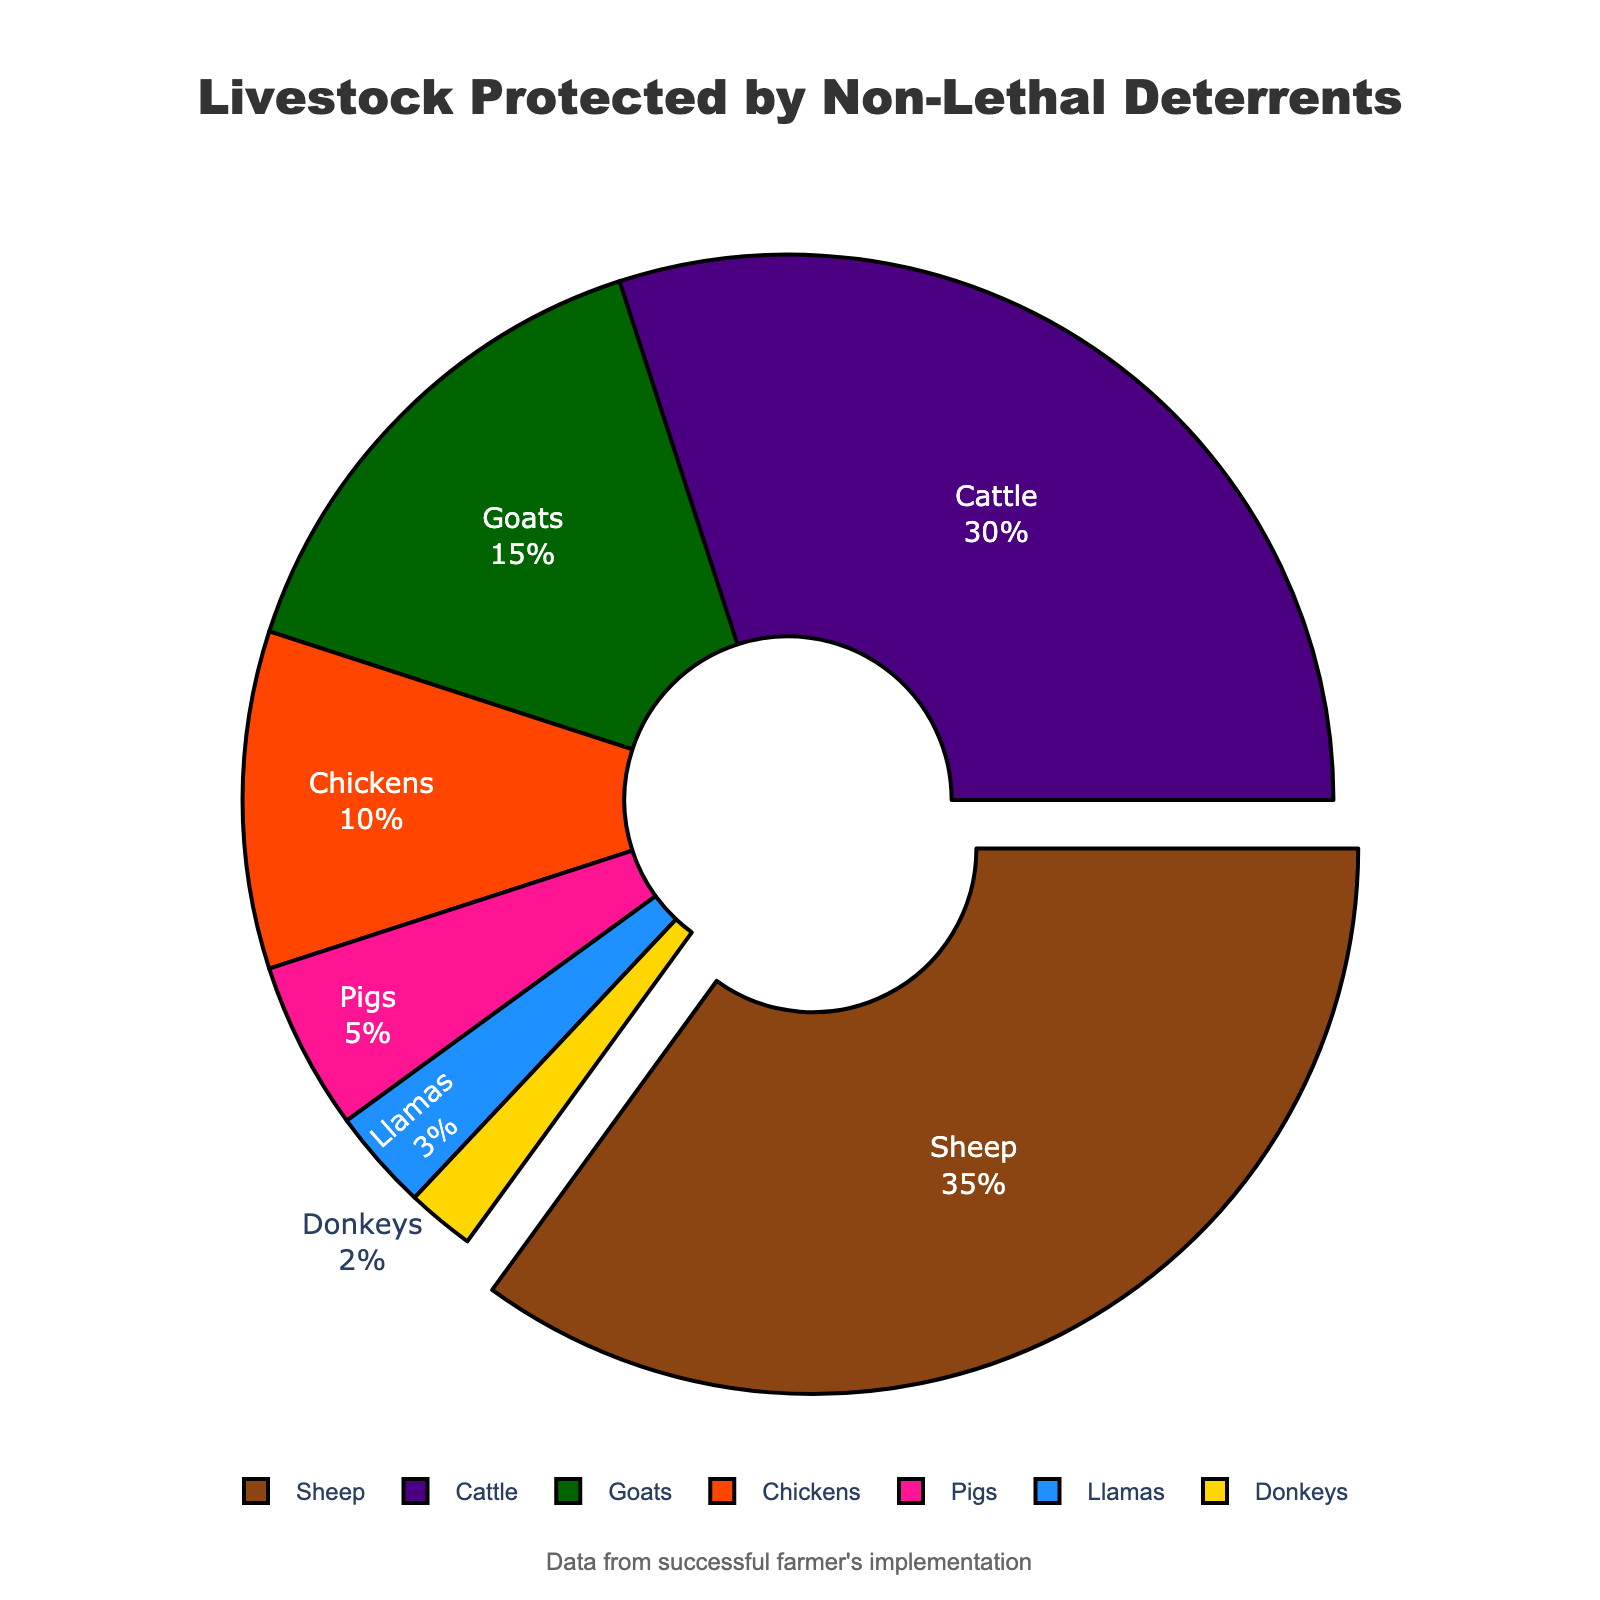What is the species with the highest percentage of livestock protected by non-lethal deterrents? The pie chart highlights the sheep segment by slightly pulling it out from the rest, indicating it has the highest percentage. Upon checking the data labels in the chart, the highest value is 35% for sheep.
Answer: Sheep How much more percentage does sheep contribute to the protected livestock compared to pigs? From the pie chart data, the percentage for sheep is 35% and for pigs, it is 5%. The difference between them is 35% - 5%.
Answer: 30% What is the total percentage of livestock protected by non-lethal deterrents for cattle and goats combined? The chart shows that cattle have a percentage of 30% and goats have 15%. Adding these two percentages gives 30% + 15%.
Answer: 45% Is the percentage of chickens protected by non-lethal deterrents greater than or less than the percentage of goats? The pie chart indicates that the percentage for chickens is 10% and for goats is 15%. Thus, the percentage of chickens is less than that of goats.
Answer: Less than Which species has the least percentage representation in the chart, and what is that percentage? According to the chart, the segment representing donkeys is the smallest, and the label indicates 2%.
Answer: Donkeys, 2% What is the sum of the percentages of livestock protected that are represented by pigs, llamas, and donkeys? In the chart, pigs have 5%, llamas 3%, and donkeys 2%. Adding these percentages together gives 5% + 3% + 2%.
Answer: 10% Which species comprise less than 10% each of the total livestock protected by non-lethal deterrents? By carefully looking at the chart, the species with less than 10% are pigs (5%), llamas (3%), and donkeys (2%).
Answer: Pigs, Llamas, Donkeys What is the average percentage representation of sheep, cattle, and goats? The pie chart shows sheep at 35%, cattle at 30%, and goats at 15%. The average percentage is calculated by summing these values and dividing by 3: (35% + 30% + 15%) / 3.
Answer: 26.67% 